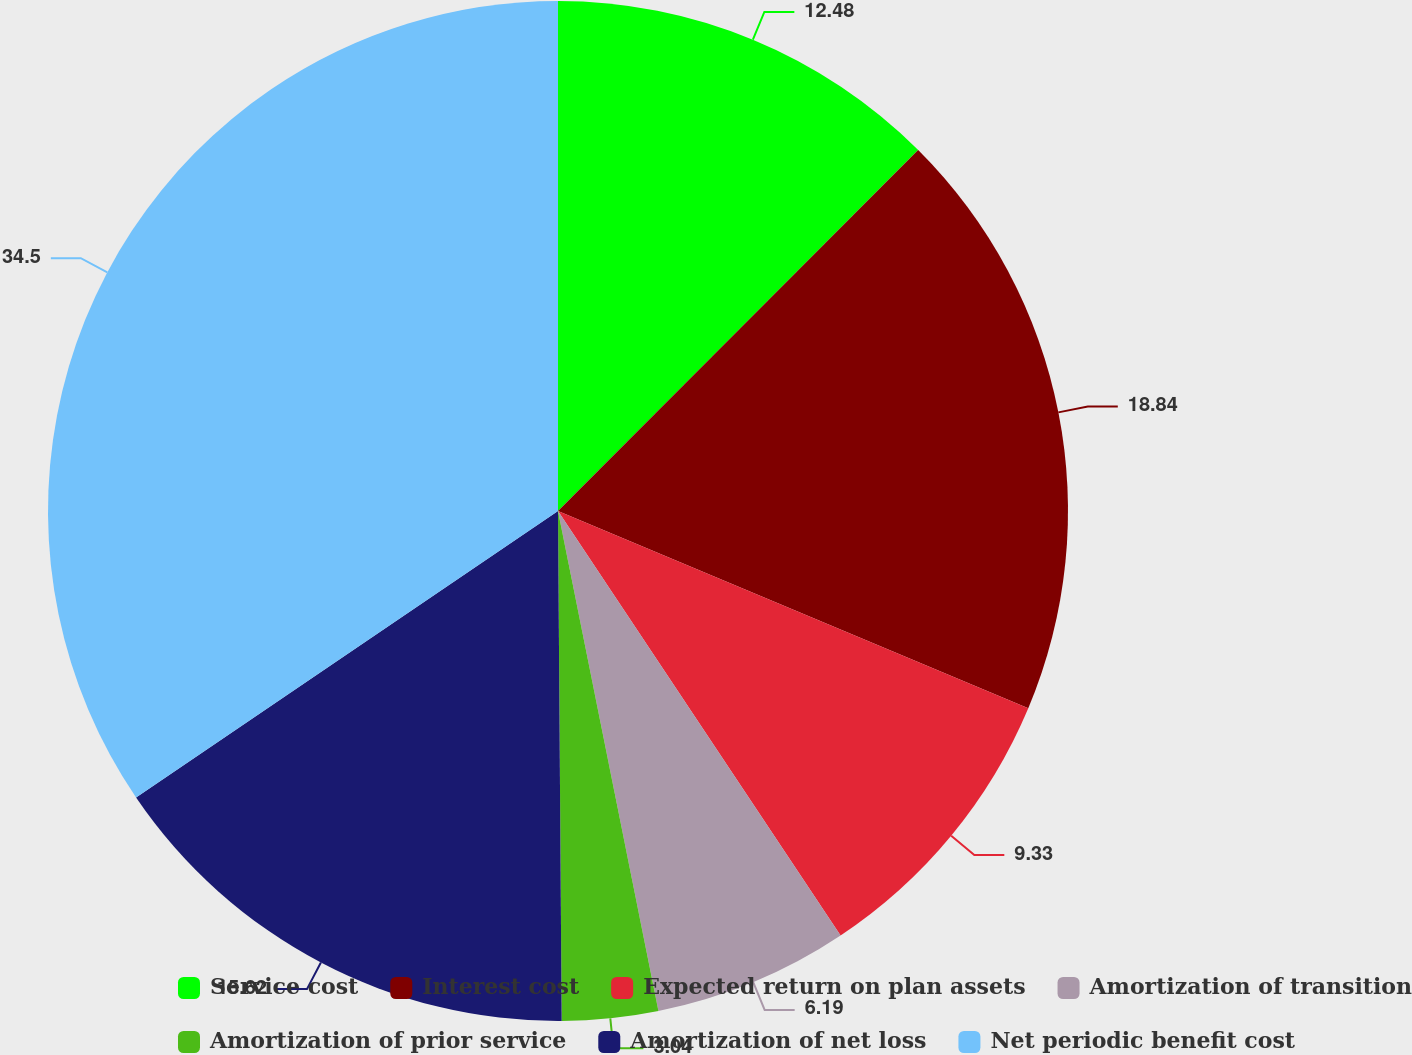Convert chart. <chart><loc_0><loc_0><loc_500><loc_500><pie_chart><fcel>Service cost<fcel>Interest cost<fcel>Expected return on plan assets<fcel>Amortization of transition<fcel>Amortization of prior service<fcel>Amortization of net loss<fcel>Net periodic benefit cost<nl><fcel>12.48%<fcel>18.84%<fcel>9.33%<fcel>6.19%<fcel>3.04%<fcel>15.62%<fcel>34.49%<nl></chart> 